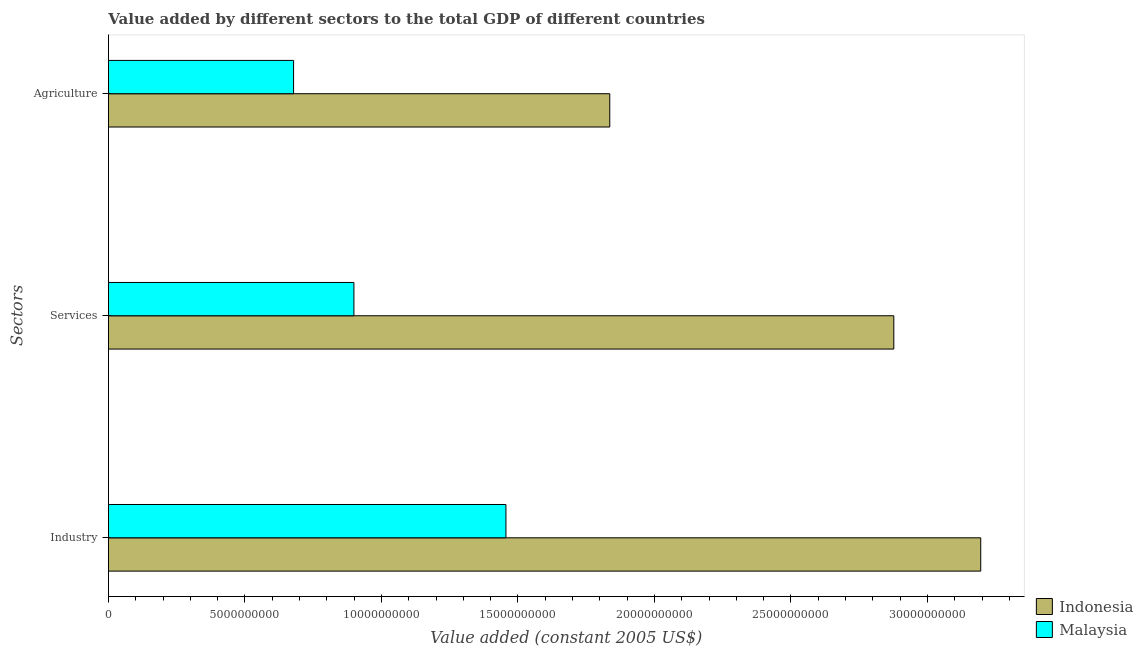How many different coloured bars are there?
Provide a short and direct response. 2. How many groups of bars are there?
Offer a terse response. 3. Are the number of bars per tick equal to the number of legend labels?
Ensure brevity in your answer.  Yes. What is the label of the 2nd group of bars from the top?
Offer a terse response. Services. What is the value added by services in Indonesia?
Keep it short and to the point. 2.88e+1. Across all countries, what is the maximum value added by agricultural sector?
Make the answer very short. 1.84e+1. Across all countries, what is the minimum value added by agricultural sector?
Give a very brief answer. 6.78e+09. In which country was the value added by industrial sector maximum?
Provide a succinct answer. Indonesia. In which country was the value added by agricultural sector minimum?
Provide a short and direct response. Malaysia. What is the total value added by services in the graph?
Keep it short and to the point. 3.78e+1. What is the difference between the value added by agricultural sector in Indonesia and that in Malaysia?
Your answer should be compact. 1.16e+1. What is the difference between the value added by agricultural sector in Indonesia and the value added by industrial sector in Malaysia?
Your answer should be compact. 3.80e+09. What is the average value added by industrial sector per country?
Offer a very short reply. 2.33e+1. What is the difference between the value added by services and value added by agricultural sector in Indonesia?
Give a very brief answer. 1.04e+1. In how many countries, is the value added by industrial sector greater than 32000000000 US$?
Offer a very short reply. 0. What is the ratio of the value added by industrial sector in Indonesia to that in Malaysia?
Make the answer very short. 2.19. Is the value added by industrial sector in Malaysia less than that in Indonesia?
Provide a succinct answer. Yes. Is the difference between the value added by services in Malaysia and Indonesia greater than the difference between the value added by agricultural sector in Malaysia and Indonesia?
Ensure brevity in your answer.  No. What is the difference between the highest and the second highest value added by services?
Provide a short and direct response. 1.98e+1. What is the difference between the highest and the lowest value added by services?
Make the answer very short. 1.98e+1. In how many countries, is the value added by services greater than the average value added by services taken over all countries?
Your response must be concise. 1. What does the 1st bar from the top in Industry represents?
Offer a terse response. Malaysia. Is it the case that in every country, the sum of the value added by industrial sector and value added by services is greater than the value added by agricultural sector?
Offer a very short reply. Yes. How many bars are there?
Provide a short and direct response. 6. Are all the bars in the graph horizontal?
Offer a very short reply. Yes. Are the values on the major ticks of X-axis written in scientific E-notation?
Make the answer very short. No. Does the graph contain grids?
Give a very brief answer. No. Where does the legend appear in the graph?
Ensure brevity in your answer.  Bottom right. How are the legend labels stacked?
Offer a terse response. Vertical. What is the title of the graph?
Keep it short and to the point. Value added by different sectors to the total GDP of different countries. Does "Swaziland" appear as one of the legend labels in the graph?
Give a very brief answer. No. What is the label or title of the X-axis?
Provide a short and direct response. Value added (constant 2005 US$). What is the label or title of the Y-axis?
Your answer should be compact. Sectors. What is the Value added (constant 2005 US$) of Indonesia in Industry?
Your response must be concise. 3.20e+1. What is the Value added (constant 2005 US$) of Malaysia in Industry?
Offer a very short reply. 1.46e+1. What is the Value added (constant 2005 US$) in Indonesia in Services?
Ensure brevity in your answer.  2.88e+1. What is the Value added (constant 2005 US$) of Malaysia in Services?
Give a very brief answer. 8.99e+09. What is the Value added (constant 2005 US$) of Indonesia in Agriculture?
Offer a very short reply. 1.84e+1. What is the Value added (constant 2005 US$) of Malaysia in Agriculture?
Make the answer very short. 6.78e+09. Across all Sectors, what is the maximum Value added (constant 2005 US$) in Indonesia?
Offer a very short reply. 3.20e+1. Across all Sectors, what is the maximum Value added (constant 2005 US$) in Malaysia?
Your response must be concise. 1.46e+1. Across all Sectors, what is the minimum Value added (constant 2005 US$) in Indonesia?
Offer a terse response. 1.84e+1. Across all Sectors, what is the minimum Value added (constant 2005 US$) in Malaysia?
Give a very brief answer. 6.78e+09. What is the total Value added (constant 2005 US$) of Indonesia in the graph?
Give a very brief answer. 7.91e+1. What is the total Value added (constant 2005 US$) of Malaysia in the graph?
Provide a short and direct response. 3.03e+1. What is the difference between the Value added (constant 2005 US$) of Indonesia in Industry and that in Services?
Your answer should be compact. 3.18e+09. What is the difference between the Value added (constant 2005 US$) of Malaysia in Industry and that in Services?
Give a very brief answer. 5.57e+09. What is the difference between the Value added (constant 2005 US$) of Indonesia in Industry and that in Agriculture?
Ensure brevity in your answer.  1.36e+1. What is the difference between the Value added (constant 2005 US$) of Malaysia in Industry and that in Agriculture?
Keep it short and to the point. 7.78e+09. What is the difference between the Value added (constant 2005 US$) of Indonesia in Services and that in Agriculture?
Provide a succinct answer. 1.04e+1. What is the difference between the Value added (constant 2005 US$) in Malaysia in Services and that in Agriculture?
Make the answer very short. 2.21e+09. What is the difference between the Value added (constant 2005 US$) of Indonesia in Industry and the Value added (constant 2005 US$) of Malaysia in Services?
Your answer should be compact. 2.30e+1. What is the difference between the Value added (constant 2005 US$) of Indonesia in Industry and the Value added (constant 2005 US$) of Malaysia in Agriculture?
Your response must be concise. 2.52e+1. What is the difference between the Value added (constant 2005 US$) in Indonesia in Services and the Value added (constant 2005 US$) in Malaysia in Agriculture?
Ensure brevity in your answer.  2.20e+1. What is the average Value added (constant 2005 US$) in Indonesia per Sectors?
Offer a terse response. 2.64e+1. What is the average Value added (constant 2005 US$) of Malaysia per Sectors?
Your answer should be very brief. 1.01e+1. What is the difference between the Value added (constant 2005 US$) of Indonesia and Value added (constant 2005 US$) of Malaysia in Industry?
Your answer should be very brief. 1.74e+1. What is the difference between the Value added (constant 2005 US$) in Indonesia and Value added (constant 2005 US$) in Malaysia in Services?
Ensure brevity in your answer.  1.98e+1. What is the difference between the Value added (constant 2005 US$) of Indonesia and Value added (constant 2005 US$) of Malaysia in Agriculture?
Make the answer very short. 1.16e+1. What is the ratio of the Value added (constant 2005 US$) in Indonesia in Industry to that in Services?
Provide a short and direct response. 1.11. What is the ratio of the Value added (constant 2005 US$) of Malaysia in Industry to that in Services?
Your response must be concise. 1.62. What is the ratio of the Value added (constant 2005 US$) in Indonesia in Industry to that in Agriculture?
Offer a terse response. 1.74. What is the ratio of the Value added (constant 2005 US$) of Malaysia in Industry to that in Agriculture?
Provide a succinct answer. 2.15. What is the ratio of the Value added (constant 2005 US$) in Indonesia in Services to that in Agriculture?
Your answer should be compact. 1.57. What is the ratio of the Value added (constant 2005 US$) in Malaysia in Services to that in Agriculture?
Give a very brief answer. 1.33. What is the difference between the highest and the second highest Value added (constant 2005 US$) of Indonesia?
Offer a very short reply. 3.18e+09. What is the difference between the highest and the second highest Value added (constant 2005 US$) in Malaysia?
Your answer should be very brief. 5.57e+09. What is the difference between the highest and the lowest Value added (constant 2005 US$) in Indonesia?
Your response must be concise. 1.36e+1. What is the difference between the highest and the lowest Value added (constant 2005 US$) in Malaysia?
Provide a succinct answer. 7.78e+09. 